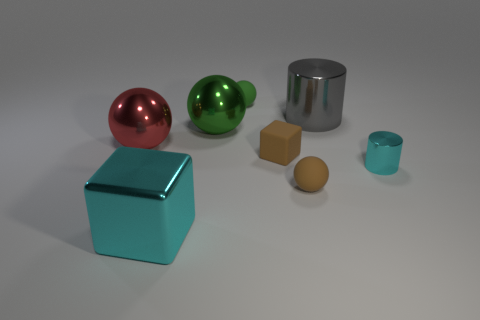Add 1 large green shiny spheres. How many objects exist? 9 Subtract all purple spheres. Subtract all purple cylinders. How many spheres are left? 4 Subtract all cylinders. How many objects are left? 6 Add 3 cyan metallic objects. How many cyan metallic objects exist? 5 Subtract 1 cyan cubes. How many objects are left? 7 Subtract all green metal balls. Subtract all tiny matte cubes. How many objects are left? 6 Add 4 big green objects. How many big green objects are left? 5 